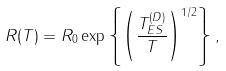<formula> <loc_0><loc_0><loc_500><loc_500>R ( T ) = R _ { 0 } \exp \left \{ \left ( \frac { T ^ { ( D ) } _ { E S } } { T } \right ) ^ { 1 / 2 } \right \} ,</formula> 